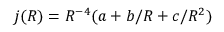Convert formula to latex. <formula><loc_0><loc_0><loc_500><loc_500>j ( R ) = R ^ { - 4 } ( a + b / R + c / R ^ { 2 } )</formula> 